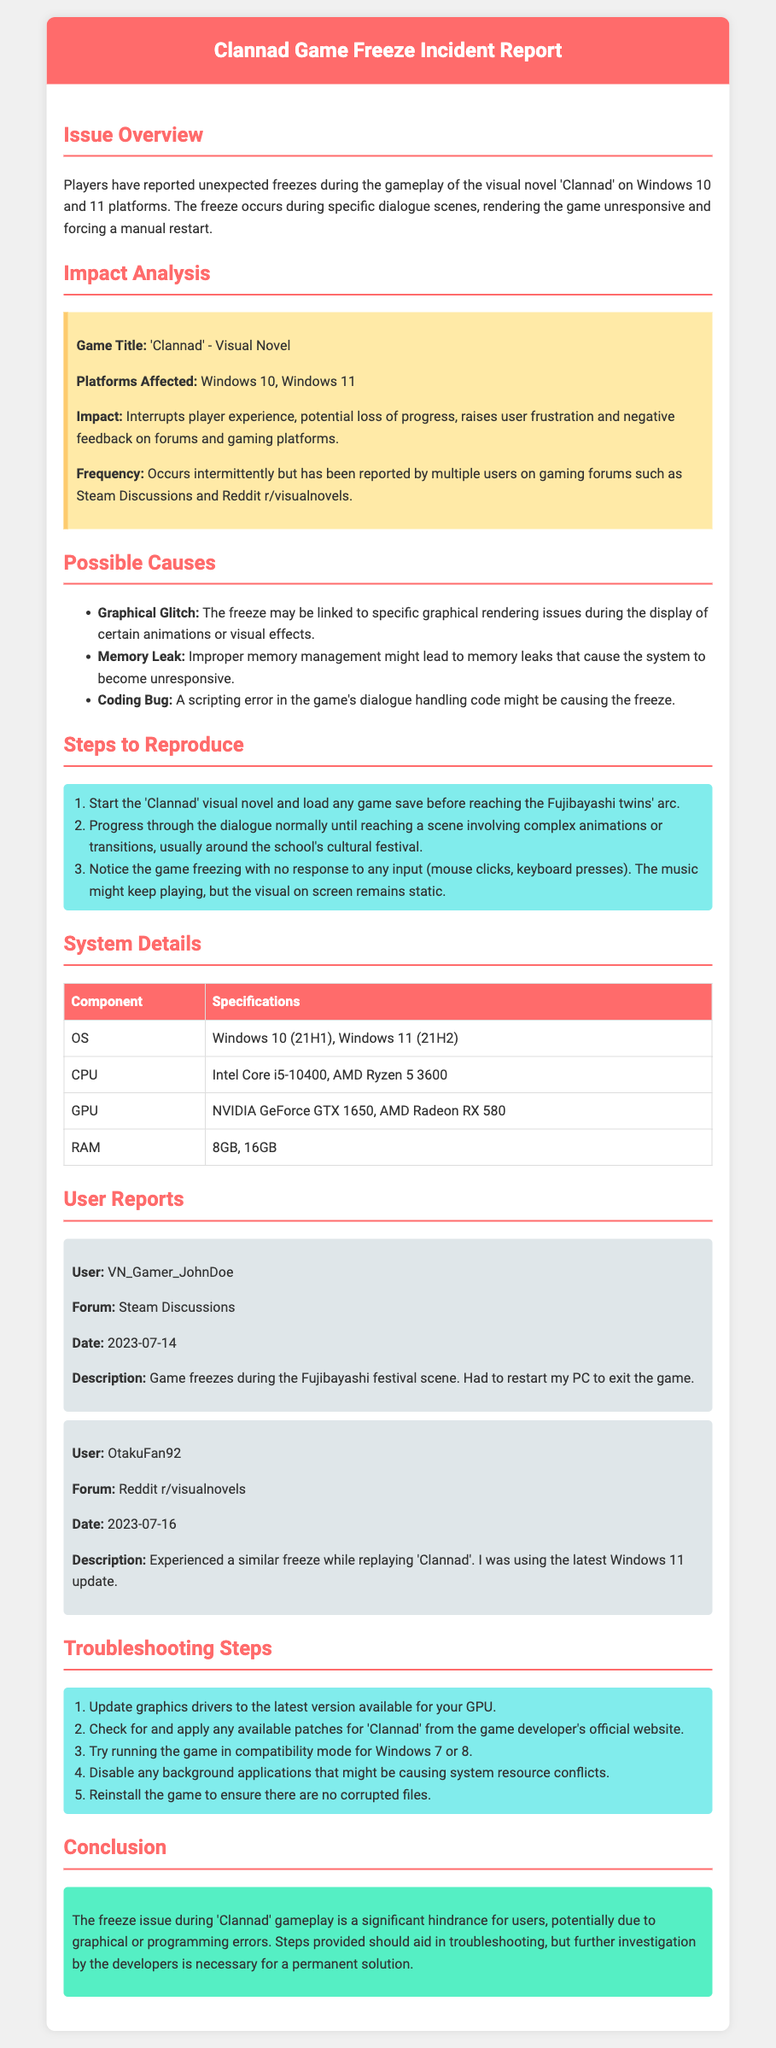what game is the report about? The report focuses on the visual novel titled 'Clannad'.
Answer: 'Clannad' what platforms are affected by the game freeze issue? The report specifies that the freeze occurs on Windows 10 and Windows 11 platforms.
Answer: Windows 10, Windows 11 how frequently does the game freeze issue occur? The document states that the issue occurs intermittently but has been reported by multiple users.
Answer: Intermittently who reported a freeze issue on Steam Discussions? The document lists a user named VN_Gamer_JohnDoe reporting the issue on Steam Discussions.
Answer: VN_Gamer_JohnDoe what is a possible cause of the game freeze? The document lists several causes, including a 'Graphical Glitch' as one of them.
Answer: Graphical Glitch how many steps are provided to reproduce the freeze issue? The report outlines three steps necessary to reproduce the freezing problem during gameplay.
Answer: Three what is the recommended action regarding graphics drivers? The troubleshooting steps suggest updating the graphics drivers to the latest version available.
Answer: Update graphics drivers what type of document is this? The document is an incident report focused on a specific gameplay issue.
Answer: Incident report what is one user description of the freeze issue? The report includes a description from OtakuFan92 noting a freeze experienced while replaying 'Clannad'.
Answer: Experienced a similar freeze while replaying 'Clannad' 